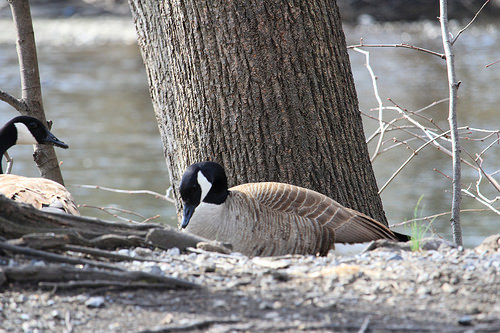<image>
Can you confirm if the goose is on the gravel? Yes. Looking at the image, I can see the goose is positioned on top of the gravel, with the gravel providing support. 